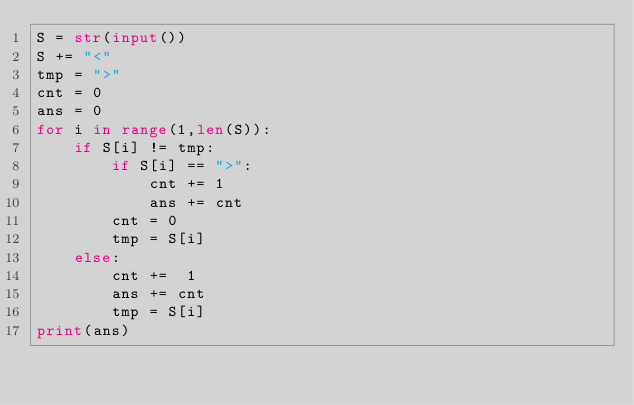<code> <loc_0><loc_0><loc_500><loc_500><_Python_>S = str(input())
S += "<"
tmp = ">"
cnt = 0
ans = 0
for i in range(1,len(S)):
    if S[i] != tmp:
        if S[i] == ">":
            cnt += 1
            ans += cnt
        cnt = 0
        tmp = S[i]
    else:
        cnt +=  1
        ans += cnt
        tmp = S[i]
print(ans)</code> 